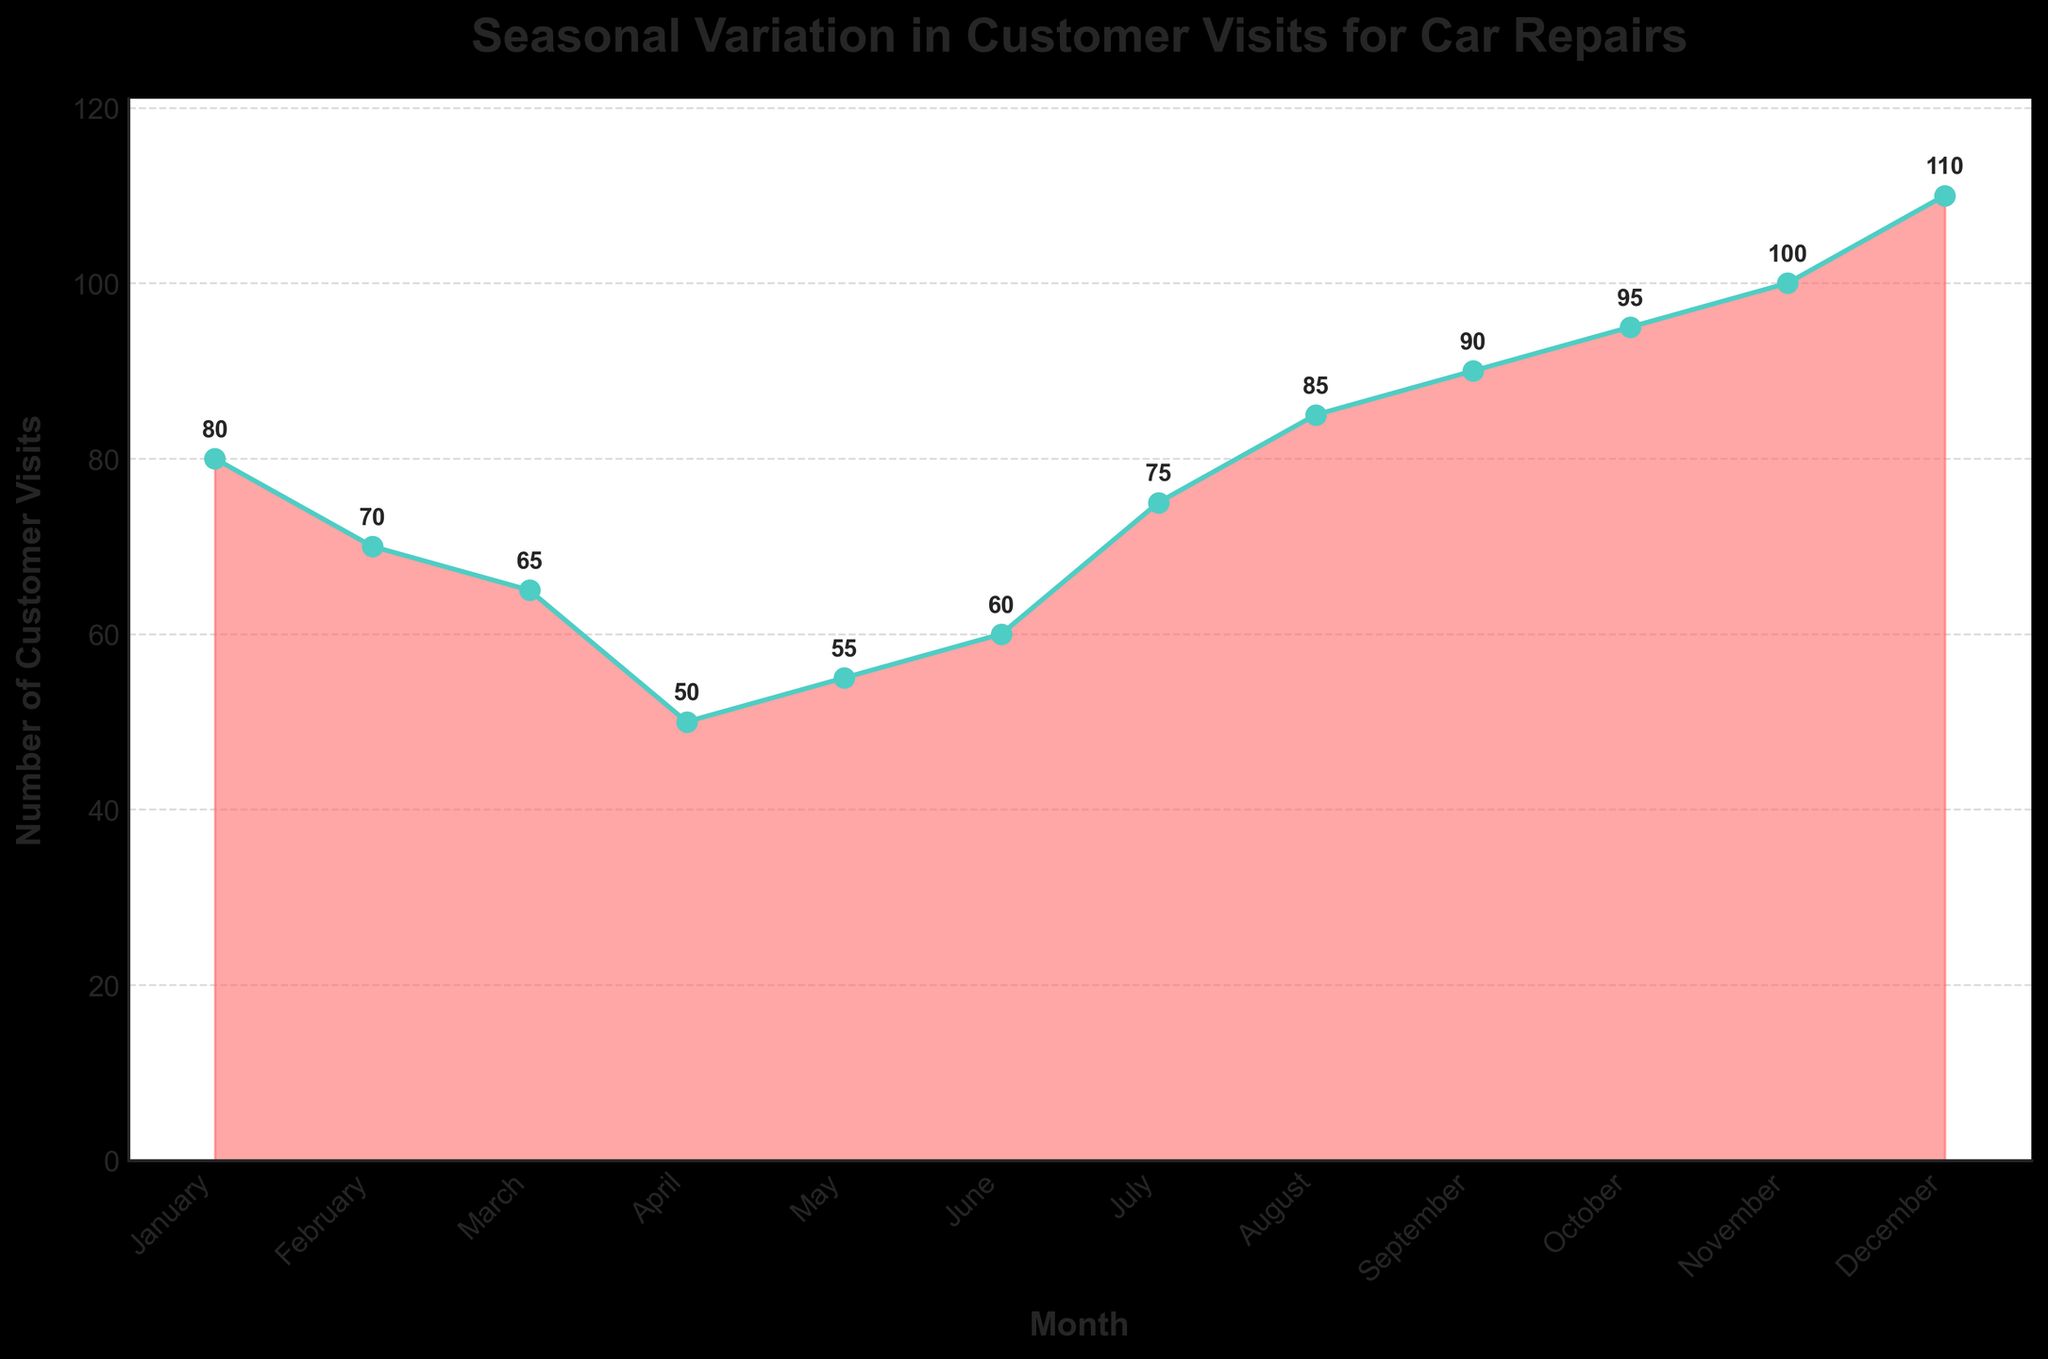How many customer visits were recorded in December? According to the figure, the number of customer visits in December is shown at the top of the bar for that month.
Answer: 110 What is the title of the chart? The title of the chart is typically located at the top of the figure.
Answer: Seasonal Variation in Customer Visits for Car Repairs Which month had the least number of customer visits? To find the month with the least visits, look for the month with the lowest point on the chart.
Answer: April How many more customer visits were there in December compared to January? First, find the number of visits in December (110) and January (80), then subtract January's visits from December's. 110 - 80 = 30
Answer: 30 How does the number of customer visits change from June to July? Compare the number of visits in June (60) to the number in July (75). July has more visits than June.
Answer: Increases What is the trend in customer visits from August to December? To determine the trend, observe the changes in visit numbers from August (85) to December (110) on the chart.
Answer: Increasing Which month shows the highest number of customer visits? Find the month with the highest value on the chart, which is the peak point.
Answer: December What is the average number of customer visits per month? Add up all the customer visits for each month and divide by 12 (the number of months). (80 + 70 + 65 + 50 + 55 + 60 + 75 + 85 + 90 + 95 + 100 + 110) / 12 = 77.5
Answer: 77.5 By how much did customer visits change between November and December? Find the difference between the visits in November (100) and December (110). 110 - 100 = 10
Answer: 10 Which months show customer visits lower than the average monthly visits? First, calculate the average (77.5), then identify the months with visits below this number: March (65), April (50), May (55), June (60).
Answer: March, April, May, June 